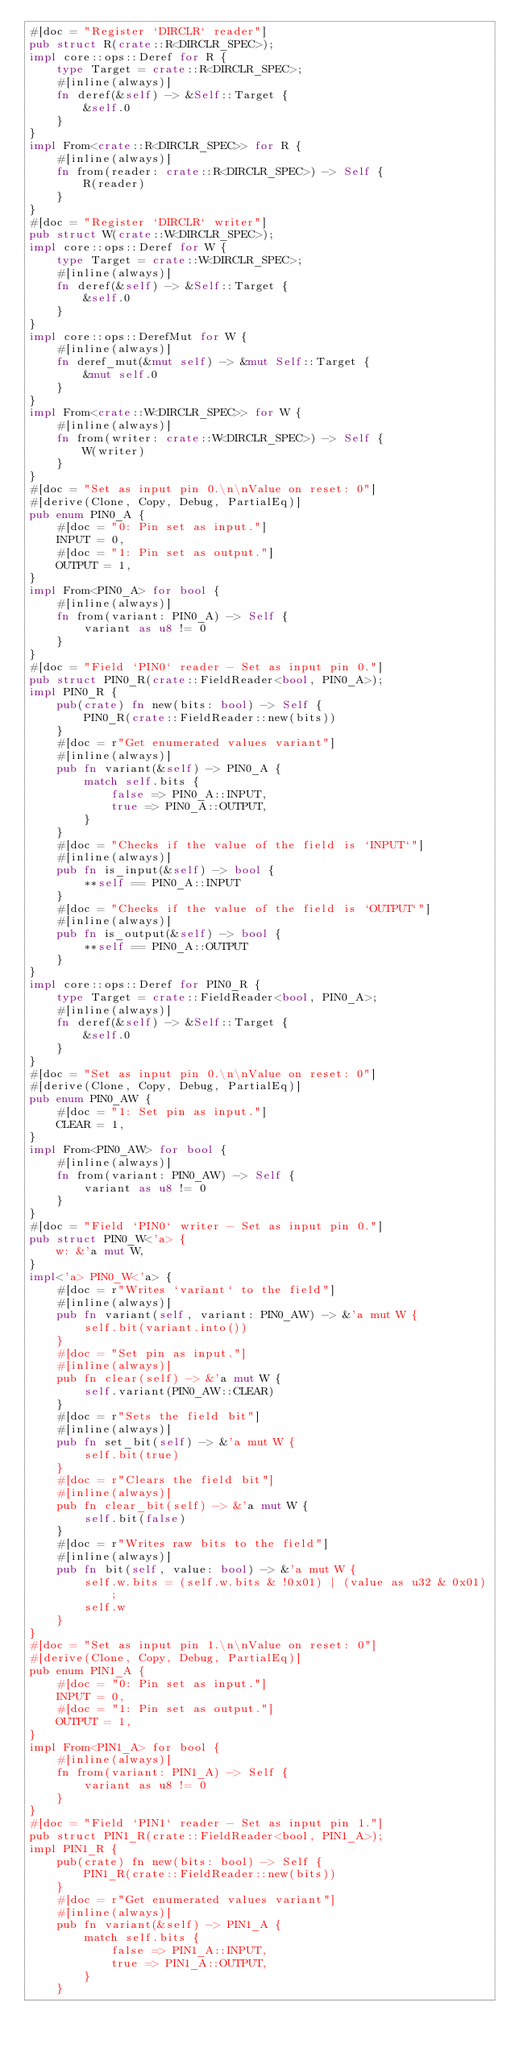Convert code to text. <code><loc_0><loc_0><loc_500><loc_500><_Rust_>#[doc = "Register `DIRCLR` reader"]
pub struct R(crate::R<DIRCLR_SPEC>);
impl core::ops::Deref for R {
    type Target = crate::R<DIRCLR_SPEC>;
    #[inline(always)]
    fn deref(&self) -> &Self::Target {
        &self.0
    }
}
impl From<crate::R<DIRCLR_SPEC>> for R {
    #[inline(always)]
    fn from(reader: crate::R<DIRCLR_SPEC>) -> Self {
        R(reader)
    }
}
#[doc = "Register `DIRCLR` writer"]
pub struct W(crate::W<DIRCLR_SPEC>);
impl core::ops::Deref for W {
    type Target = crate::W<DIRCLR_SPEC>;
    #[inline(always)]
    fn deref(&self) -> &Self::Target {
        &self.0
    }
}
impl core::ops::DerefMut for W {
    #[inline(always)]
    fn deref_mut(&mut self) -> &mut Self::Target {
        &mut self.0
    }
}
impl From<crate::W<DIRCLR_SPEC>> for W {
    #[inline(always)]
    fn from(writer: crate::W<DIRCLR_SPEC>) -> Self {
        W(writer)
    }
}
#[doc = "Set as input pin 0.\n\nValue on reset: 0"]
#[derive(Clone, Copy, Debug, PartialEq)]
pub enum PIN0_A {
    #[doc = "0: Pin set as input."]
    INPUT = 0,
    #[doc = "1: Pin set as output."]
    OUTPUT = 1,
}
impl From<PIN0_A> for bool {
    #[inline(always)]
    fn from(variant: PIN0_A) -> Self {
        variant as u8 != 0
    }
}
#[doc = "Field `PIN0` reader - Set as input pin 0."]
pub struct PIN0_R(crate::FieldReader<bool, PIN0_A>);
impl PIN0_R {
    pub(crate) fn new(bits: bool) -> Self {
        PIN0_R(crate::FieldReader::new(bits))
    }
    #[doc = r"Get enumerated values variant"]
    #[inline(always)]
    pub fn variant(&self) -> PIN0_A {
        match self.bits {
            false => PIN0_A::INPUT,
            true => PIN0_A::OUTPUT,
        }
    }
    #[doc = "Checks if the value of the field is `INPUT`"]
    #[inline(always)]
    pub fn is_input(&self) -> bool {
        **self == PIN0_A::INPUT
    }
    #[doc = "Checks if the value of the field is `OUTPUT`"]
    #[inline(always)]
    pub fn is_output(&self) -> bool {
        **self == PIN0_A::OUTPUT
    }
}
impl core::ops::Deref for PIN0_R {
    type Target = crate::FieldReader<bool, PIN0_A>;
    #[inline(always)]
    fn deref(&self) -> &Self::Target {
        &self.0
    }
}
#[doc = "Set as input pin 0.\n\nValue on reset: 0"]
#[derive(Clone, Copy, Debug, PartialEq)]
pub enum PIN0_AW {
    #[doc = "1: Set pin as input."]
    CLEAR = 1,
}
impl From<PIN0_AW> for bool {
    #[inline(always)]
    fn from(variant: PIN0_AW) -> Self {
        variant as u8 != 0
    }
}
#[doc = "Field `PIN0` writer - Set as input pin 0."]
pub struct PIN0_W<'a> {
    w: &'a mut W,
}
impl<'a> PIN0_W<'a> {
    #[doc = r"Writes `variant` to the field"]
    #[inline(always)]
    pub fn variant(self, variant: PIN0_AW) -> &'a mut W {
        self.bit(variant.into())
    }
    #[doc = "Set pin as input."]
    #[inline(always)]
    pub fn clear(self) -> &'a mut W {
        self.variant(PIN0_AW::CLEAR)
    }
    #[doc = r"Sets the field bit"]
    #[inline(always)]
    pub fn set_bit(self) -> &'a mut W {
        self.bit(true)
    }
    #[doc = r"Clears the field bit"]
    #[inline(always)]
    pub fn clear_bit(self) -> &'a mut W {
        self.bit(false)
    }
    #[doc = r"Writes raw bits to the field"]
    #[inline(always)]
    pub fn bit(self, value: bool) -> &'a mut W {
        self.w.bits = (self.w.bits & !0x01) | (value as u32 & 0x01);
        self.w
    }
}
#[doc = "Set as input pin 1.\n\nValue on reset: 0"]
#[derive(Clone, Copy, Debug, PartialEq)]
pub enum PIN1_A {
    #[doc = "0: Pin set as input."]
    INPUT = 0,
    #[doc = "1: Pin set as output."]
    OUTPUT = 1,
}
impl From<PIN1_A> for bool {
    #[inline(always)]
    fn from(variant: PIN1_A) -> Self {
        variant as u8 != 0
    }
}
#[doc = "Field `PIN1` reader - Set as input pin 1."]
pub struct PIN1_R(crate::FieldReader<bool, PIN1_A>);
impl PIN1_R {
    pub(crate) fn new(bits: bool) -> Self {
        PIN1_R(crate::FieldReader::new(bits))
    }
    #[doc = r"Get enumerated values variant"]
    #[inline(always)]
    pub fn variant(&self) -> PIN1_A {
        match self.bits {
            false => PIN1_A::INPUT,
            true => PIN1_A::OUTPUT,
        }
    }</code> 